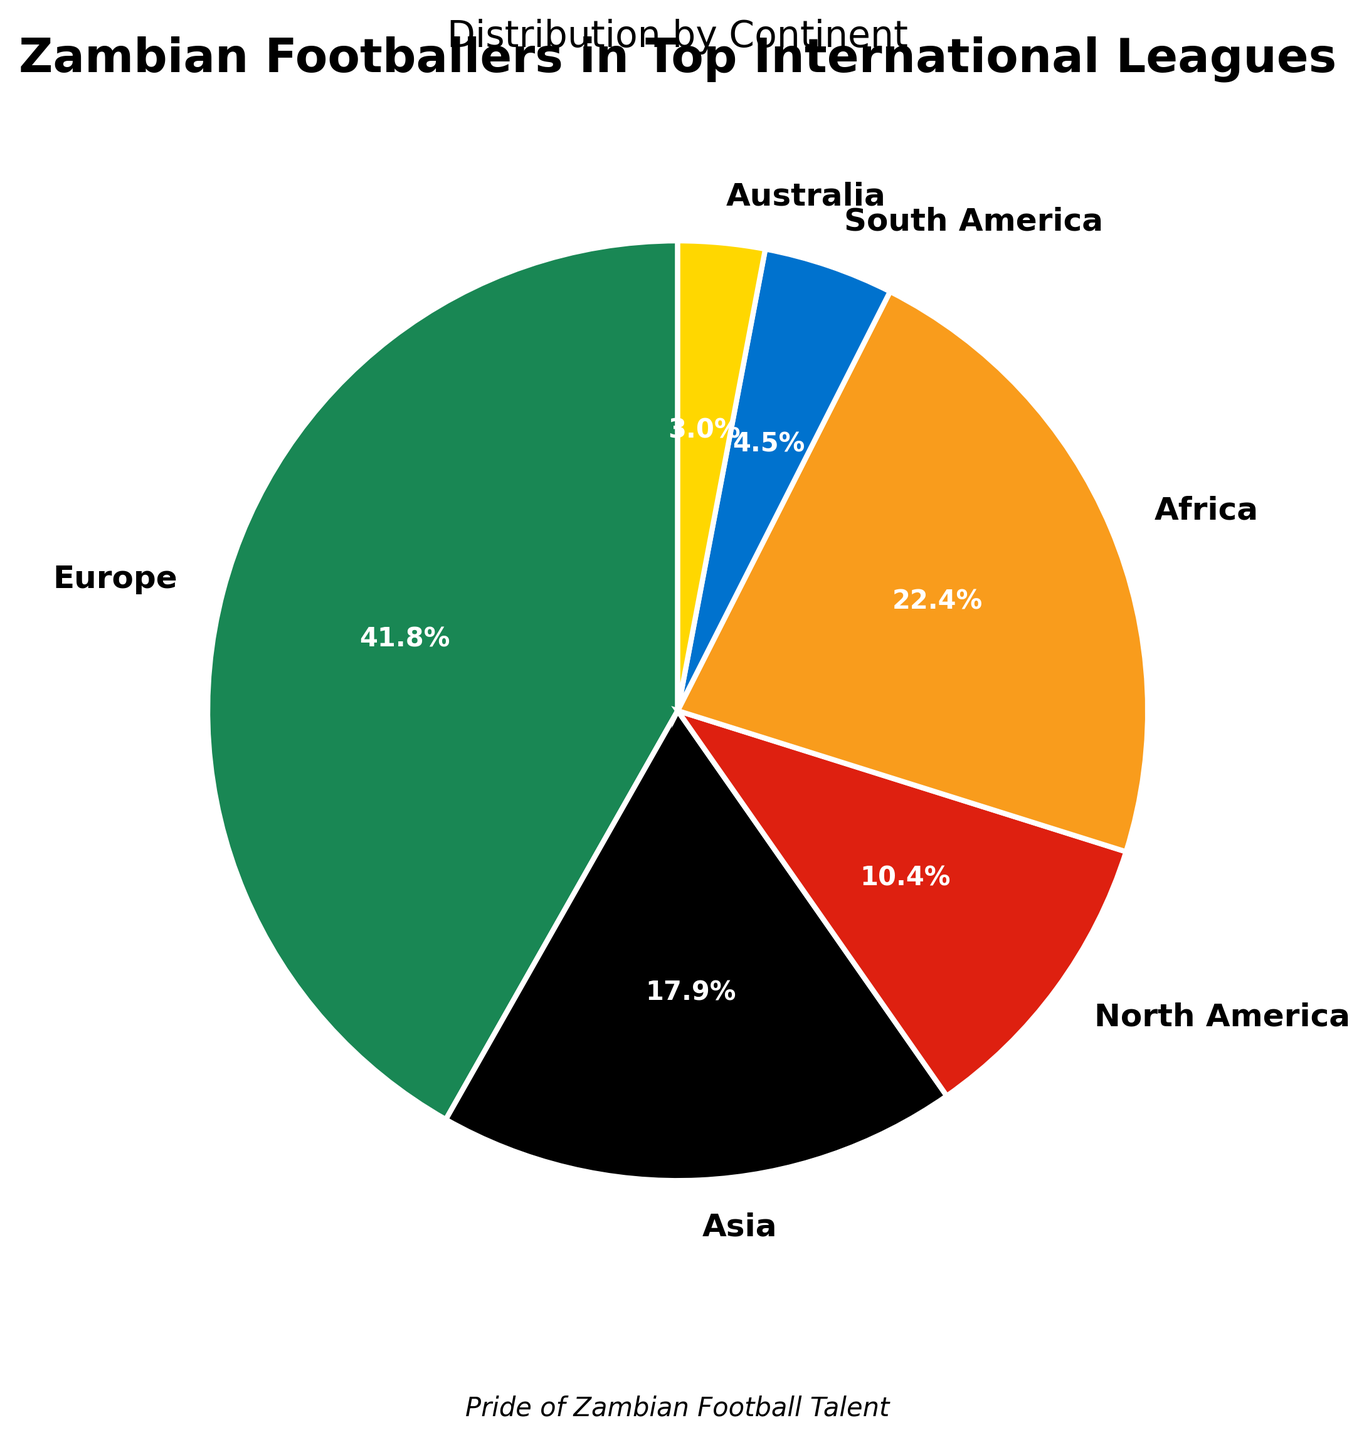Which continent has the largest number of Zambian footballers? The pie chart shows that Europe has the largest slice, indicating the most significant number of players.
Answer: Europe What percentage of Zambian footballers play in North America? The wedge labeled North America indicates 7 players, and the pie chart percentage annotation shows 7.2%.
Answer: 7.2% How many more Zambian footballers play in Africa than in South America? Africa has 15 players and South America has 3 players. Subtracting the two gives 15 - 3 = 12.
Answer: 12 Compare the number of Zambian footballers playing in Europe with those playing in Australia. Europe has 28 players, which is far more than Australia's 2 players.
Answer: Europe has more What is the combined percentage of Zambian footballers playing in Europe and Africa? Europe’s percentage is shown as 38.9% and Africa’s is 20.8%. Adding them up gives 38.9% + 20.8% = 59.7%.
Answer: 59.7% Which continents have fewer than 5% of Zambian footballers? Reviewing the slices, South America (4.2%) and Australia (2.8%) are both fewer than 5%.
Answer: South America and Australia If you combined the number of players in Asia and North America, how does that number compare to the number of players in Europe? Asia has 12 players and North America has 7 players. Combining gives 12 + 7 = 19 players, which is less than Europe’s 28 players.
Answer: Less What is the color associated with the continent of Africa in the chart? Observing the pie chart, Africa is represented by the orange slice.
Answer: Orange What proportion of Zambian footballers play in continents other than Europe and Africa? Subtract Europe and Africa's players from the total: 67 - (28 + 15) = 24 players. Then the percentage is (24/67) × 100 ≈ 35.8%.
Answer: 35.8% Which continent has the smallest number of Zambian footballers? Australia has the smallest number, represented by the smallest slice and the lowest number of 2 players.
Answer: Australia 